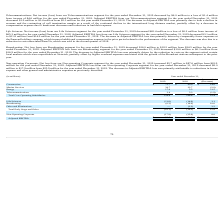According to Hc2 Holdings's financial document, What was the net income from the Construction segment for the year ended December 31, 2019? Based on the financial document, the answer is $24.7 million. Also, What caused the decrease in adjusted EBITDA? Based on the financial document, the answer is driven by a decline in income from equity method investees, due to HMN driven by lower revenues on large turnkey projects underway than in the comparable period, and losses at SBSS from a loss contingency related to ongoing legal disputes and lower vessel utilization.. Also, What was the net income from Marine Services in 2018? Based on the financial document, the answer is $0.3 million. Also, can you calculate: What was the percentage change in the construction value from 2018 to 2019? To answer this question, I need to perform calculations using the financial data. The calculation is: 75.7 / 60.9 - 1, which equals 24.3 (percentage). This is based on the information: "Construction $ 75.7 $ 60.9 $ 14.8 Construction $ 75.7 $ 60.9 $ 14.8..." The key data points involved are: 60.9, 75.7. Also, can you calculate: What was the average Marine Services value for 2018 and 2019? To answer this question, I need to perform calculations using the financial data. The calculation is: (30.7 + 32.7) / 2, which equals 31.7 (in millions). This is based on the information: "Marine Services 30.7 32.7 (2.0) Marine Services 30.7 32.7 (2.0)..." The key data points involved are: 30.7, 32.7. Also, can you calculate: What is the percentage change in Energy value from 2018 to 2019? To answer this question, I need to perform calculations using the financial data. The calculation is: 17.0 / 5.5 - 1, which equals 209.09 (percentage). This is based on the information: "Energy 17.0 5.5 11.5 Energy 17.0 5.5 11.5..." The key data points involved are: 17.0, 5.5. 